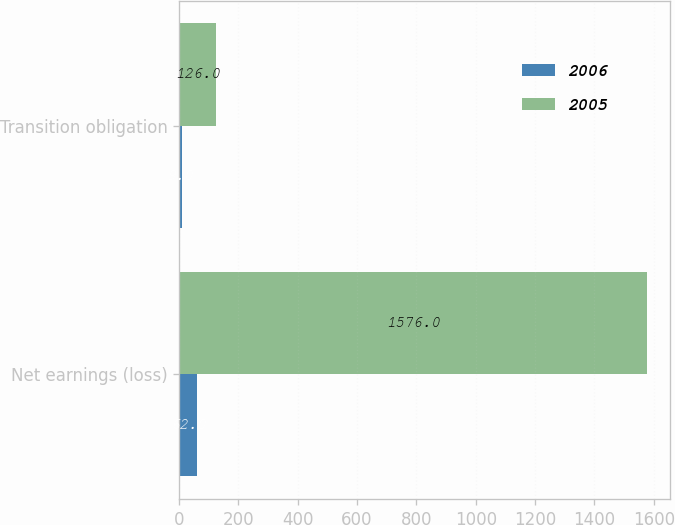Convert chart. <chart><loc_0><loc_0><loc_500><loc_500><stacked_bar_chart><ecel><fcel>Net earnings (loss)<fcel>Transition obligation<nl><fcel>2006<fcel>62<fcel>9<nl><fcel>2005<fcel>1576<fcel>126<nl></chart> 